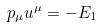<formula> <loc_0><loc_0><loc_500><loc_500>p _ { \mu } u ^ { \mu } = - E _ { 1 }</formula> 